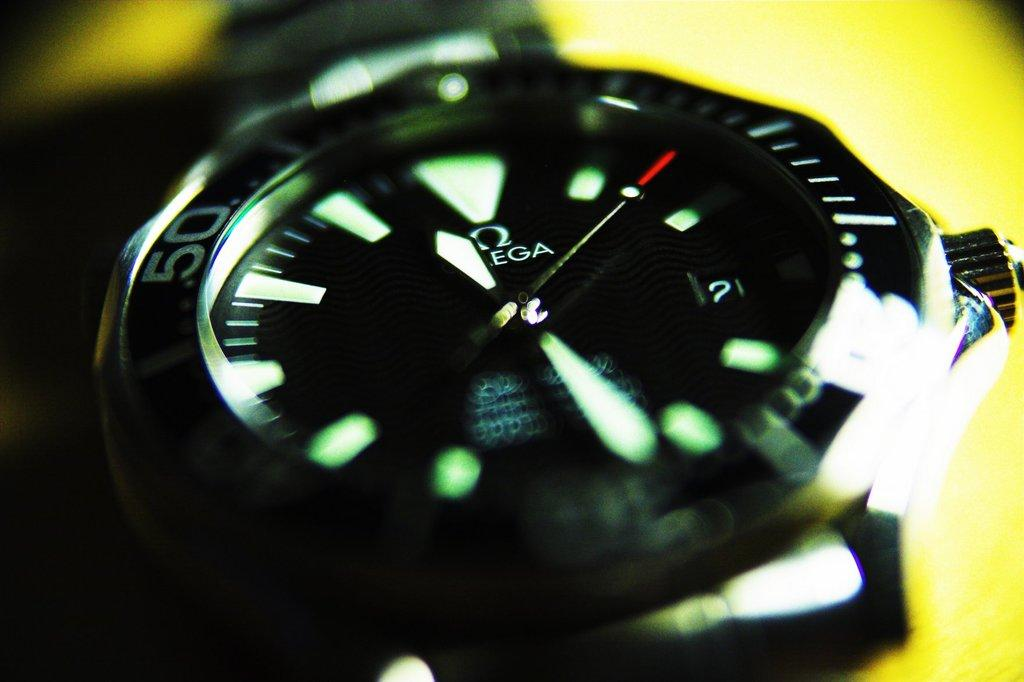<image>
Give a short and clear explanation of the subsequent image. An Omega brand watch is displayed on a yellow background. 